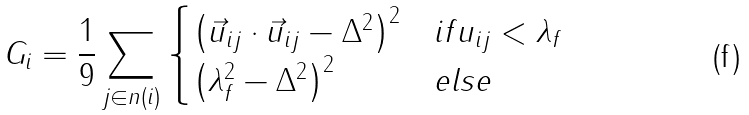<formula> <loc_0><loc_0><loc_500><loc_500>G _ { i } = \frac { 1 } { 9 } \sum _ { j \in n ( i ) } \begin{cases} \left ( \vec { u } _ { i j } \cdot \vec { u } _ { i j } - \Delta ^ { 2 } \right ) ^ { 2 } & i f u _ { i j } < \lambda _ { f } \\ \left ( \lambda _ { f } ^ { 2 } - \Delta ^ { 2 } \right ) ^ { 2 } & e l s e \end{cases}</formula> 